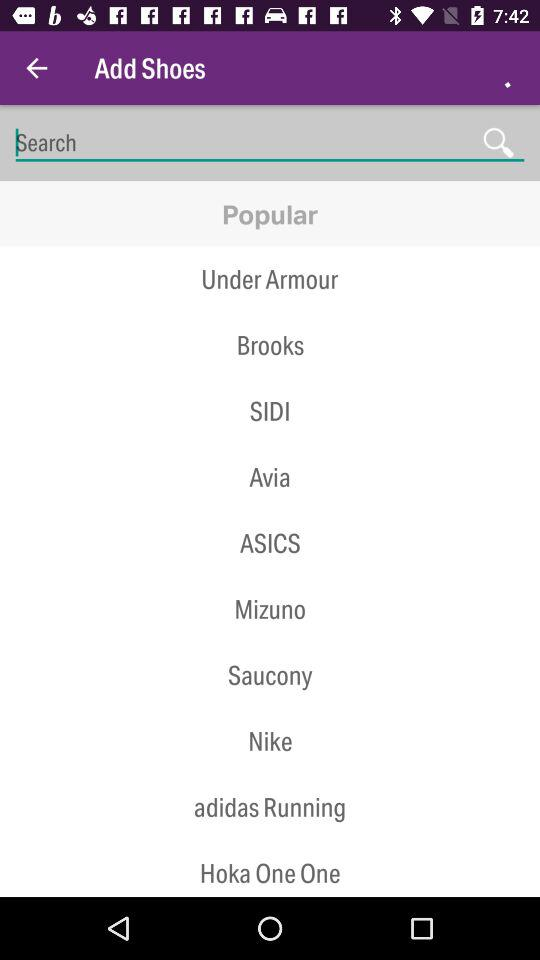How many shoes are featured on the popular tab?
Answer the question using a single word or phrase. 10 